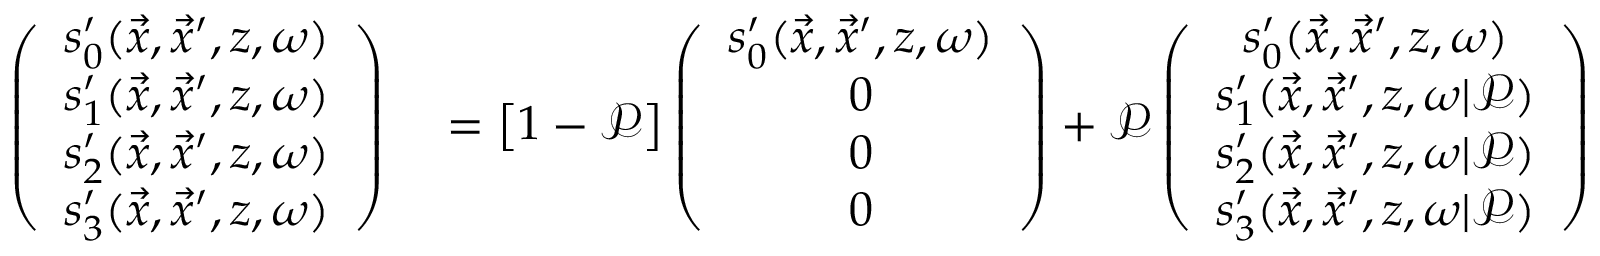<formula> <loc_0><loc_0><loc_500><loc_500>\begin{array} { r l } { \left ( \begin{array} { c } { s _ { 0 } ^ { \prime } ( \vec { x } , \vec { x } ^ { \prime } , z , \omega ) } \\ { s _ { 1 } ^ { \prime } ( \vec { x } , \vec { x } ^ { \prime } , z , \omega ) } \\ { s _ { 2 } ^ { \prime } ( \vec { x } , \vec { x } ^ { \prime } , z , \omega ) } \\ { s _ { 3 } ^ { \prime } ( \vec { x } , \vec { x } ^ { \prime } , z , \omega ) } \end{array} \right ) } & = \left [ 1 - \mathcal { P } \right ] \left ( \begin{array} { c } { s _ { 0 } ^ { \prime } ( \vec { x } , \vec { x } ^ { \prime } , z , \omega ) } \\ { 0 } \\ { 0 } \\ { 0 } \end{array} \right ) + \mathcal { P } \left ( \begin{array} { c } { s _ { 0 } ^ { \prime } ( \vec { x } , \vec { x } ^ { \prime } , z , \omega ) } \\ { s _ { 1 } ^ { \prime } ( \vec { x } , \vec { x } ^ { \prime } , z , \omega | \mathcal { P } ) } \\ { s _ { 2 } ^ { \prime } ( \vec { x } , \vec { x } ^ { \prime } , z , \omega | \mathcal { P } ) } \\ { s _ { 3 } ^ { \prime } ( \vec { x } , \vec { x } ^ { \prime } , z , \omega | \mathcal { P } ) } \end{array} \right ) } \end{array}</formula> 